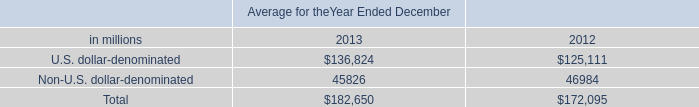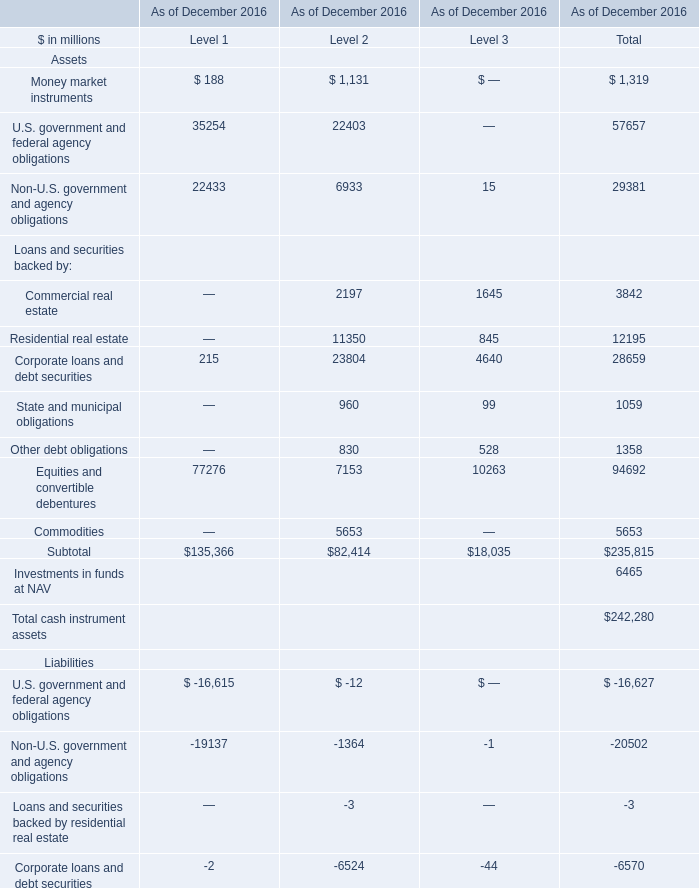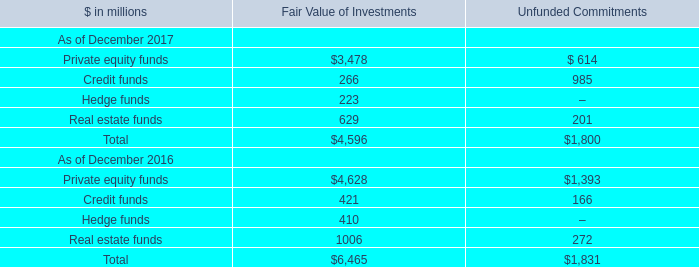as of december 2013 and december 2012 , what was the average fair value of the securities and certain overnight cash deposits included in gce , in billions? 
Computations: ((184.07 + 174.62) / 2)
Answer: 179.345. 